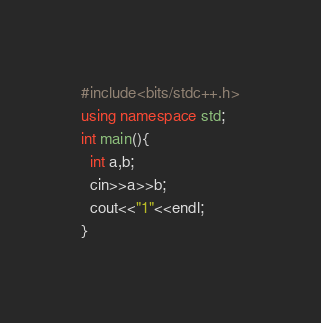<code> <loc_0><loc_0><loc_500><loc_500><_C++_>#include<bits/stdc++.h>
using namespace std;
int main(){
  int a,b;
  cin>>a>>b;
  cout<<"1"<<endl;
}</code> 